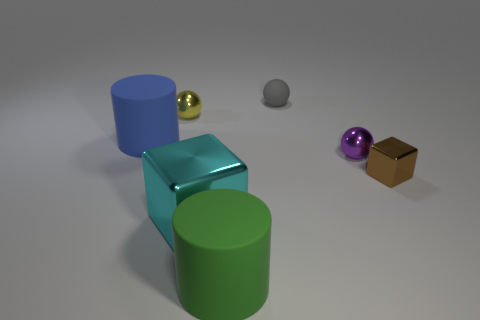Subtract all metallic spheres. How many spheres are left? 1 Add 1 rubber spheres. How many objects exist? 8 Subtract all cylinders. How many objects are left? 5 Add 5 purple shiny balls. How many purple shiny balls exist? 6 Subtract 0 blue spheres. How many objects are left? 7 Subtract all tiny purple metallic things. Subtract all big blue matte cylinders. How many objects are left? 5 Add 2 big shiny things. How many big shiny things are left? 3 